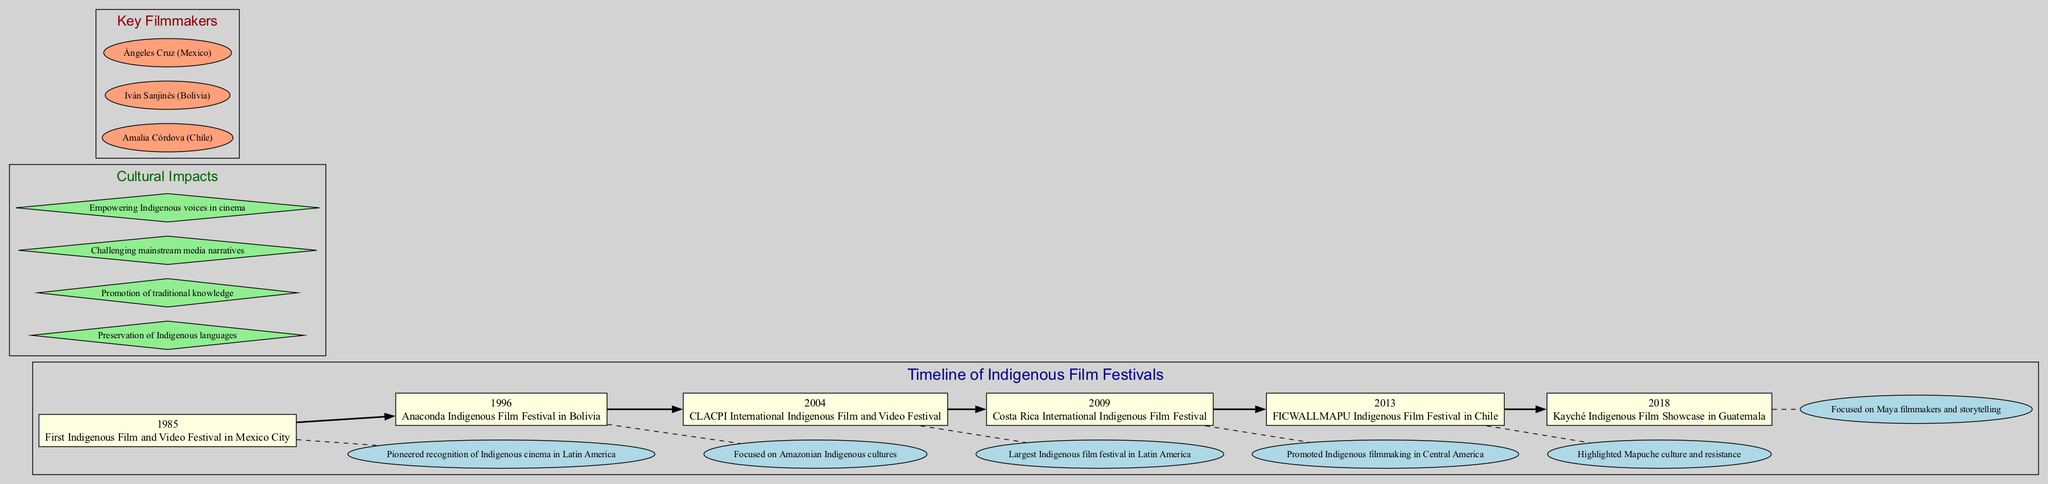What year did the first Indigenous Film and Video Festival take place? The diagram shows "1985" as the year for the event "First Indigenous Film and Video Festival in Mexico City."
Answer: 1985 How many key filmmakers are listed in the diagram? By counting the nodes in the "Key Filmmakers" section, there are three filmmakers mentioned.
Answer: 3 What cultural impact is related to "Empowering Indigenous voices in cinema"? The diagram lists "Empowering Indigenous voices in cinema" as one of the cultural impacts, which can be found in the "Cultural Impacts" cluster.
Answer: Empowering Indigenous voices in cinema Which event highlighted Mapuche culture? The event "FICWALLMAPU Indigenous Film Festival in Chile" from 2013 is specifically noted for its significance in highlighting Mapuche culture and resistance.
Answer: FICWALLMAPU Indigenous Film Festival in Chile What is the significance of the 2004 festival in the timeline? The significance of the "CLACPI International Indigenous Film and Video Festival" is noted as "Largest Indigenous film festival in Latin America," which is the relevant information for this event.
Answer: Largest Indigenous film festival in Latin America How are the cultural impacts visually represented in the diagram? Cultural impacts are represented using diamond-shaped nodes, with each impact listed separately in the "Cultural Impacts" cluster.
Answer: Diamond-shaped nodes What does the dashed line between each event indicate? The dashed line indicates a significance relationship, meaning each festival is connected to its cultural importance described in the ellipse node adjacent to it.
Answer: Significance relationship Which festival specifically focuses on Maya filmmakers? The event "Kayché Indigenous Film Showcase in Guatemala" focuses on Maya filmmakers and storytelling, as highlighted in the timeline.
Answer: Kayché Indigenous Film Showcase in Guatemala What event occurred in Costa Rica regarding Indigenous films? The "Costa Rica International Indigenous Film Festival" held in 2009 promoted Indigenous filmmaking in Central America, being the event of interest in Costa Rica.
Answer: Costa Rica International Indigenous Film Festival 